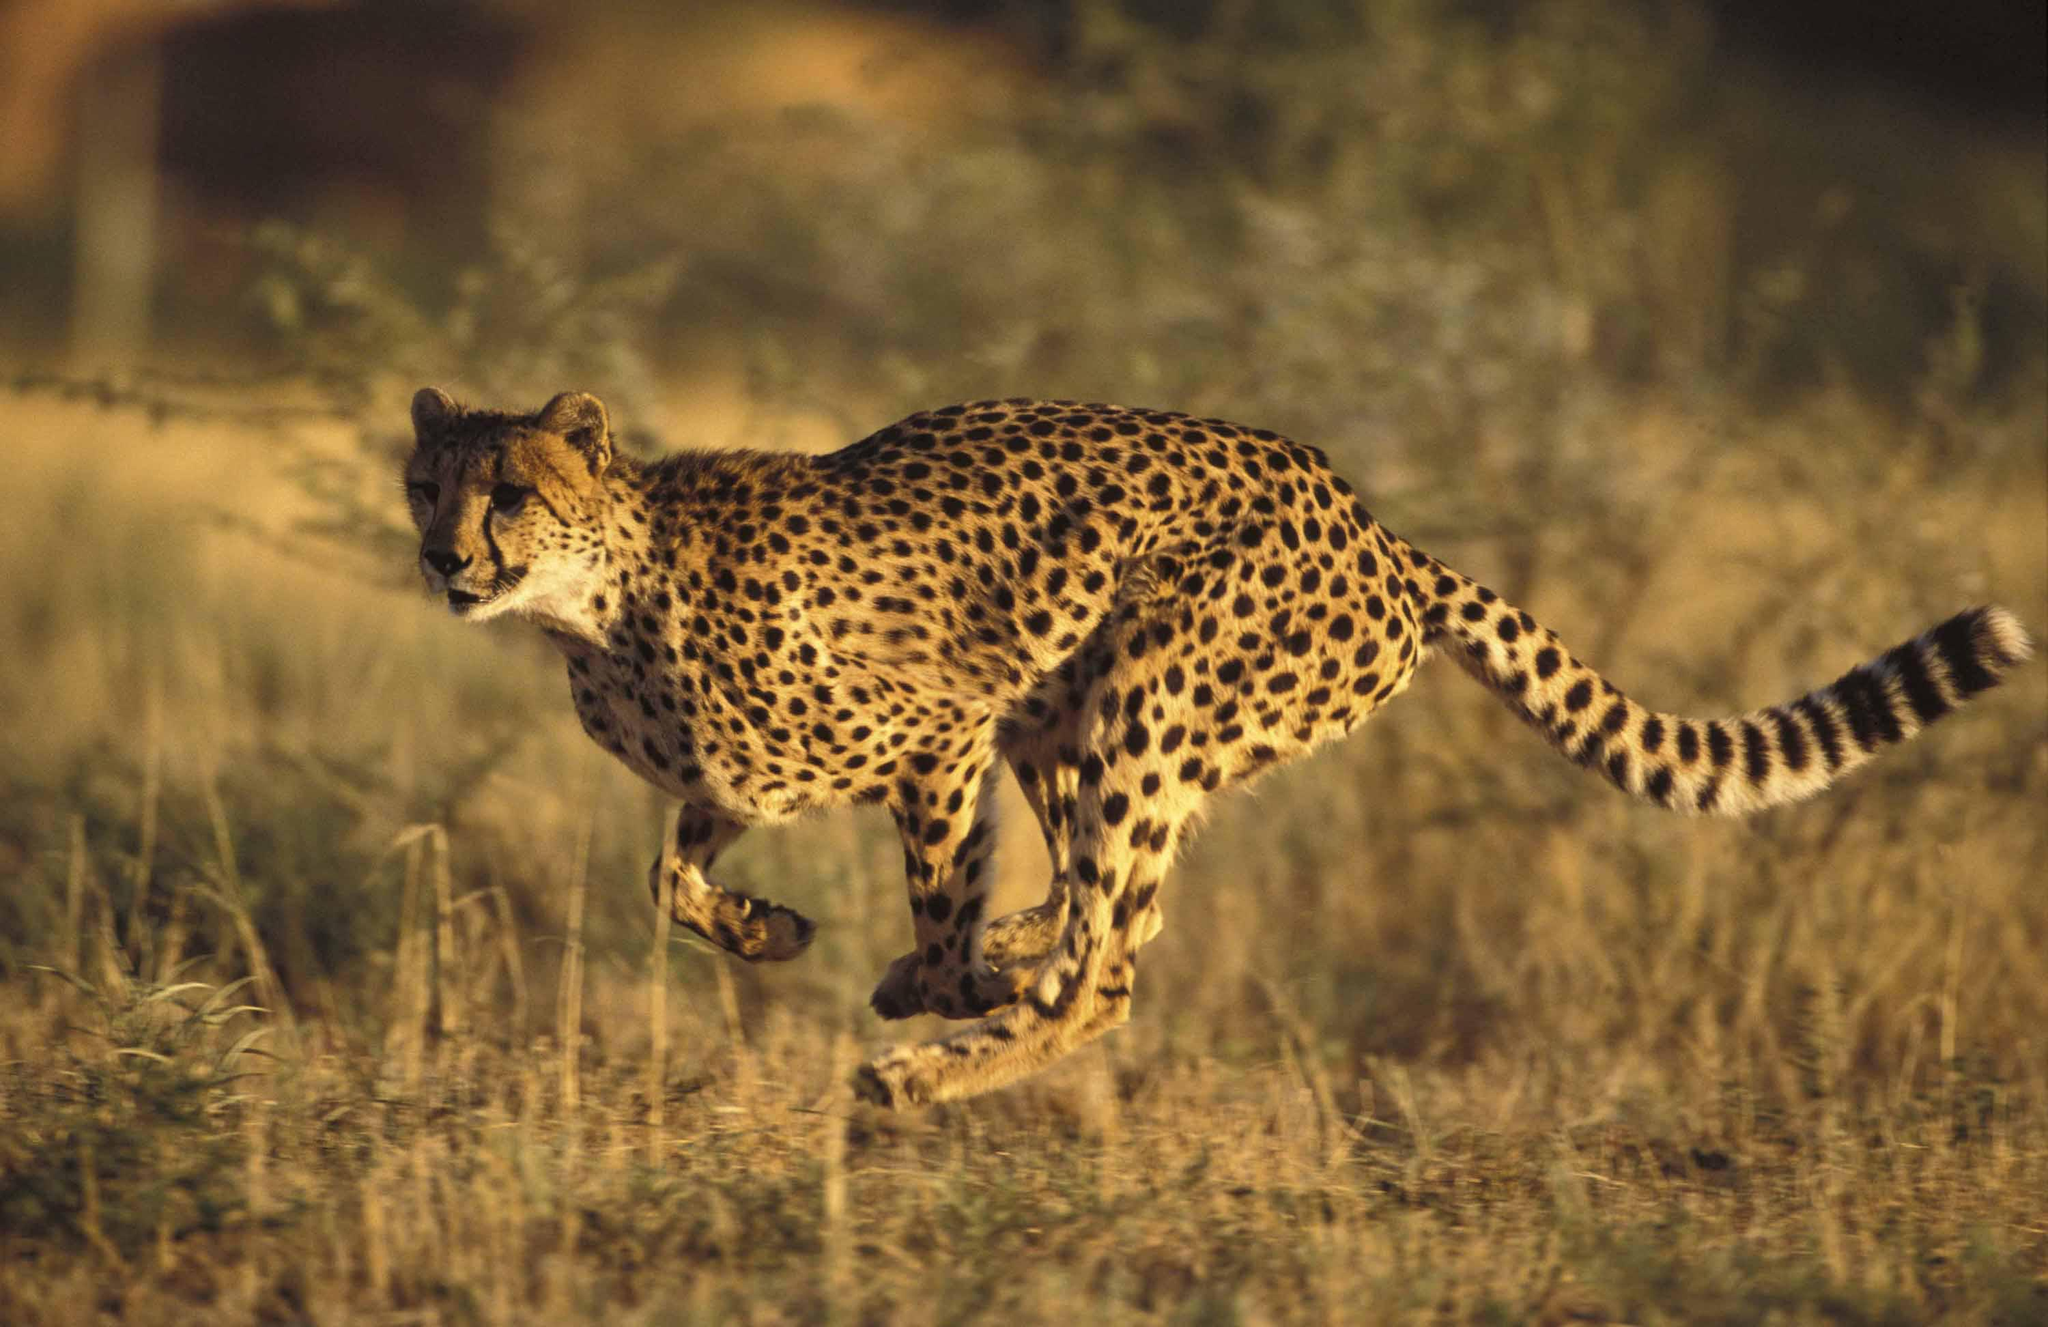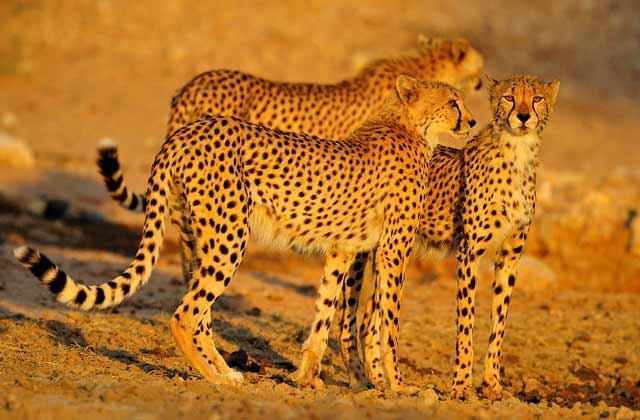The first image is the image on the left, the second image is the image on the right. Analyze the images presented: Is the assertion "At least one image contains multiple cheetahs." valid? Answer yes or no. Yes. 